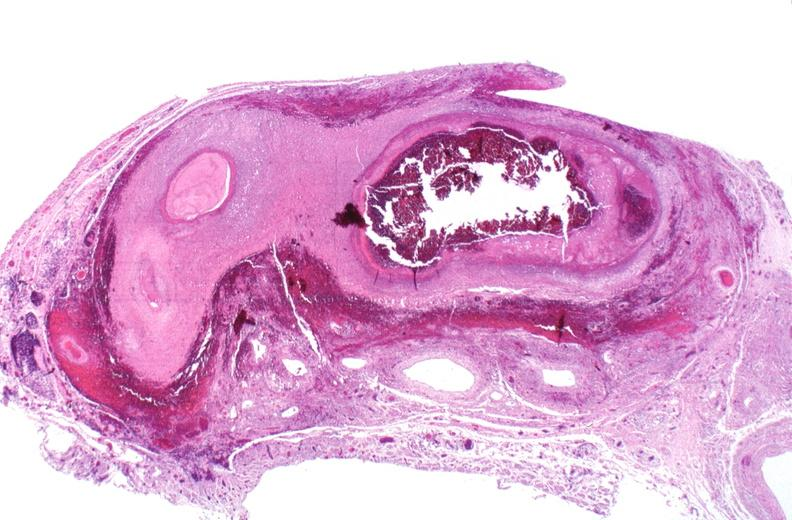does lateral view show polyarteritis nodosa?
Answer the question using a single word or phrase. No 